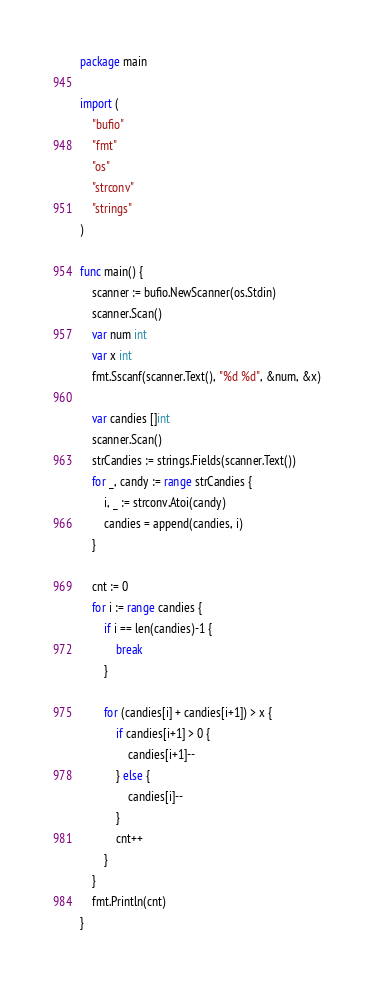<code> <loc_0><loc_0><loc_500><loc_500><_Go_>package main

import (
	"bufio"
	"fmt"
	"os"
	"strconv"
	"strings"
)

func main() {
	scanner := bufio.NewScanner(os.Stdin)
	scanner.Scan()
	var num int
	var x int
	fmt.Sscanf(scanner.Text(), "%d %d", &num, &x)

	var candies []int
	scanner.Scan()
	strCandies := strings.Fields(scanner.Text())
	for _, candy := range strCandies {
		i, _ := strconv.Atoi(candy)
		candies = append(candies, i)
	}

	cnt := 0
	for i := range candies {
		if i == len(candies)-1 {
			break
		}

		for (candies[i] + candies[i+1]) > x {
			if candies[i+1] > 0 {
				candies[i+1]--
			} else {
				candies[i]--
			}
			cnt++
		}
	}
	fmt.Println(cnt)
}
</code> 